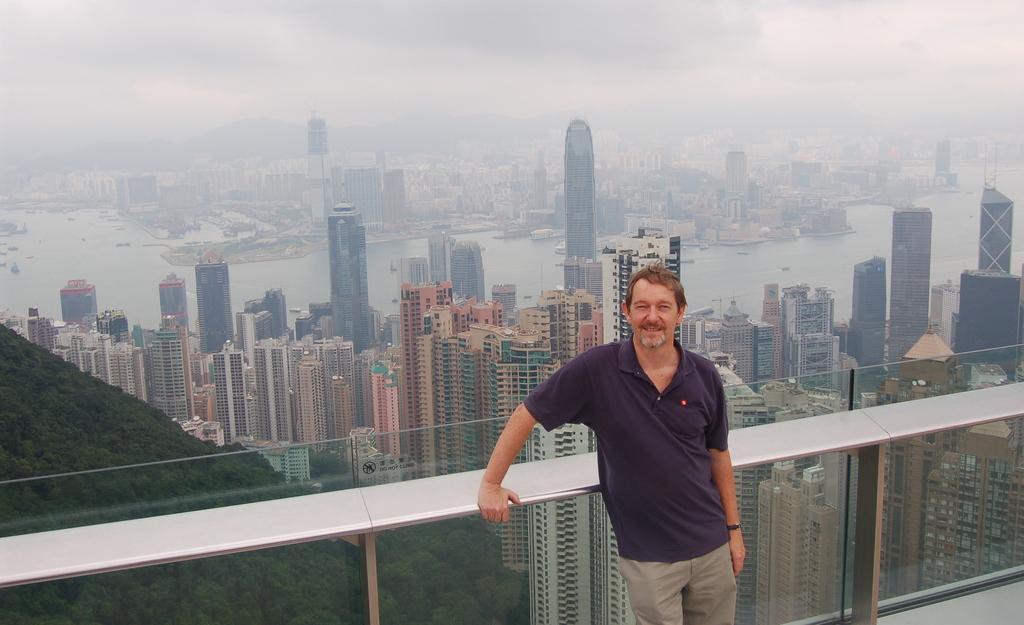Describe this image in one or two sentences. In the middle of the image a person is standing and smiling. Behind him there is fencing. Behind the fencing there are some buildings and water and hills and trees. At the top of the image there are some clouds and sky. 